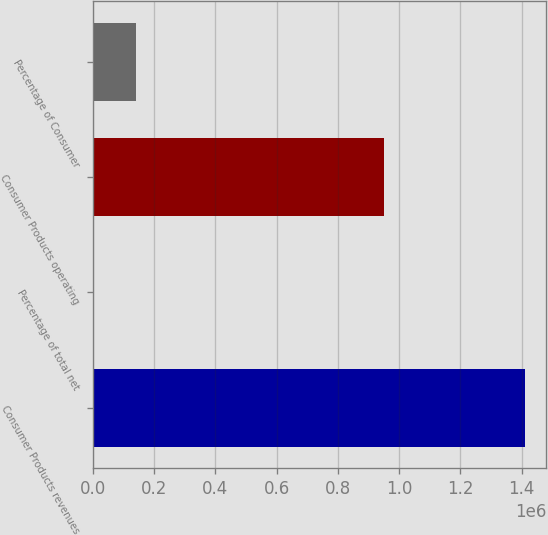Convert chart. <chart><loc_0><loc_0><loc_500><loc_500><bar_chart><fcel>Consumer Products revenues<fcel>Percentage of total net<fcel>Consumer Products operating<fcel>Percentage of Consumer<nl><fcel>1.40958e+06<fcel>34<fcel>950508<fcel>140989<nl></chart> 